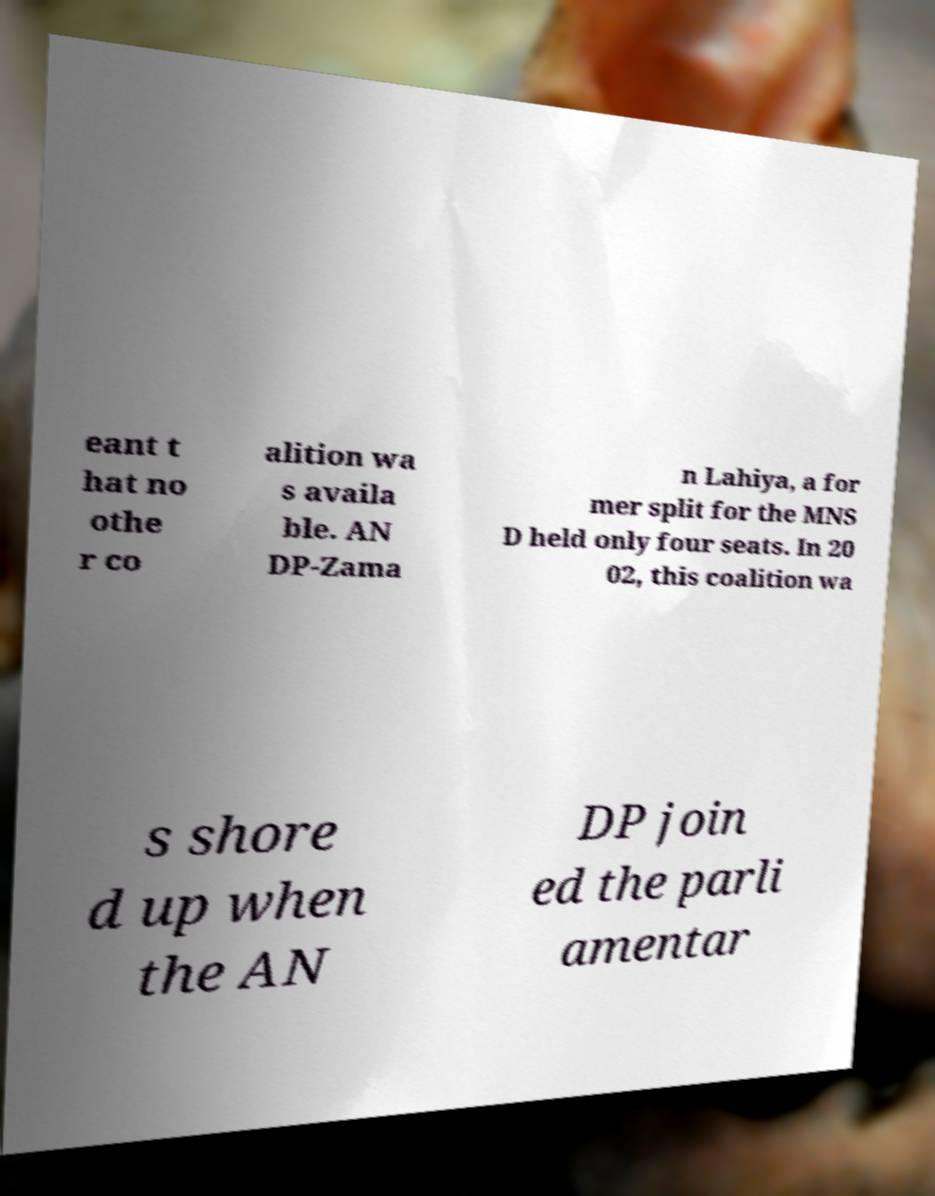Please read and relay the text visible in this image. What does it say? eant t hat no othe r co alition wa s availa ble. AN DP-Zama n Lahiya, a for mer split for the MNS D held only four seats. In 20 02, this coalition wa s shore d up when the AN DP join ed the parli amentar 